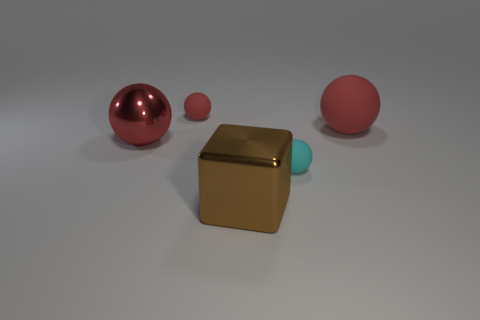What shape is the big brown shiny thing?
Your answer should be compact. Cube. What number of rubber balls are the same size as the cyan thing?
Your answer should be compact. 1. Is the big red matte object the same shape as the small red thing?
Give a very brief answer. Yes. What is the color of the tiny thing that is to the left of the shiny object in front of the red metallic thing?
Ensure brevity in your answer.  Red. What is the size of the thing that is on the right side of the small red thing and left of the small cyan rubber object?
Your answer should be compact. Large. Is there any other thing of the same color as the cube?
Provide a short and direct response. No. What is the shape of the object that is the same material as the large block?
Give a very brief answer. Sphere. Does the small red matte object have the same shape as the small rubber thing that is right of the metal block?
Offer a very short reply. Yes. What is the big ball that is to the left of the small thing to the right of the brown cube made of?
Your response must be concise. Metal. Are there an equal number of cyan balls that are left of the large brown metallic thing and yellow cubes?
Your answer should be very brief. Yes. 